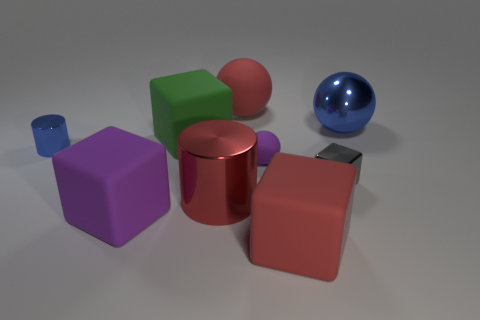How many things are either metallic things that are on the right side of the tiny gray metallic thing or tiny blue metal cylinders?
Offer a terse response. 2. Does the gray block have the same size as the red cylinder?
Make the answer very short. No. The rubber cube in front of the purple rubber cube is what color?
Offer a terse response. Red. There is a ball that is the same material as the red cylinder; what is its size?
Give a very brief answer. Large. There is a purple cube; is it the same size as the red rubber object to the right of the red ball?
Make the answer very short. Yes. There is a blue thing that is to the left of the big purple rubber thing; what material is it?
Your response must be concise. Metal. How many metal objects are behind the small metallic object to the right of the tiny purple matte sphere?
Provide a short and direct response. 2. Are there any green matte things that have the same shape as the large blue shiny thing?
Keep it short and to the point. No. There is a blue thing that is on the left side of the red rubber sphere; is its size the same as the block that is behind the small metal cylinder?
Make the answer very short. No. There is a big red rubber thing in front of the blue ball that is right of the tiny metallic block; what is its shape?
Provide a succinct answer. Cube. 